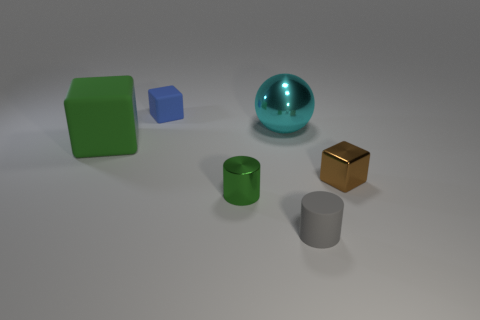Is the number of small green metallic cylinders on the right side of the metallic cylinder greater than the number of green metal objects?
Offer a terse response. No. The small cube that is behind the brown block is what color?
Offer a terse response. Blue. The shiny cylinder that is the same color as the large rubber cube is what size?
Ensure brevity in your answer.  Small. What number of metallic objects are cylinders or small blue spheres?
Make the answer very short. 1. There is a tiny rubber object behind the matte object that is right of the green cylinder; is there a small cylinder behind it?
Offer a very short reply. No. How many shiny cylinders are in front of the rubber cylinder?
Your response must be concise. 0. What material is the object that is the same color as the tiny shiny cylinder?
Your answer should be very brief. Rubber. What number of tiny objects are matte cylinders or green metal cubes?
Provide a succinct answer. 1. What shape is the small shiny object that is on the left side of the big cyan sphere?
Offer a very short reply. Cylinder. Are there any big objects of the same color as the metal sphere?
Provide a succinct answer. No. 